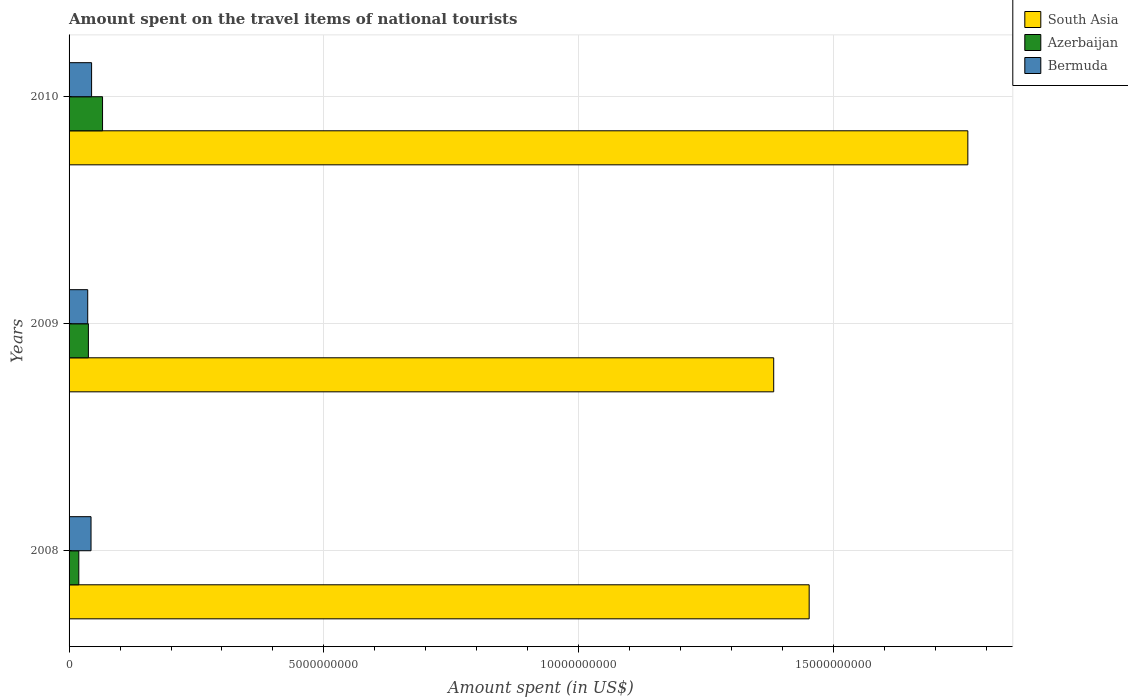How many groups of bars are there?
Your response must be concise. 3. How many bars are there on the 1st tick from the top?
Give a very brief answer. 3. What is the label of the 3rd group of bars from the top?
Your answer should be compact. 2008. What is the amount spent on the travel items of national tourists in Bermuda in 2009?
Make the answer very short. 3.66e+08. Across all years, what is the maximum amount spent on the travel items of national tourists in Bermuda?
Provide a succinct answer. 4.42e+08. Across all years, what is the minimum amount spent on the travel items of national tourists in South Asia?
Provide a short and direct response. 1.38e+1. In which year was the amount spent on the travel items of national tourists in South Asia maximum?
Provide a short and direct response. 2010. What is the total amount spent on the travel items of national tourists in South Asia in the graph?
Ensure brevity in your answer.  4.60e+1. What is the difference between the amount spent on the travel items of national tourists in Bermuda in 2008 and that in 2009?
Keep it short and to the point. 6.50e+07. What is the difference between the amount spent on the travel items of national tourists in Bermuda in 2010 and the amount spent on the travel items of national tourists in South Asia in 2009?
Your answer should be very brief. -1.34e+1. What is the average amount spent on the travel items of national tourists in Azerbaijan per year?
Ensure brevity in your answer.  4.09e+08. In the year 2008, what is the difference between the amount spent on the travel items of national tourists in Azerbaijan and amount spent on the travel items of national tourists in South Asia?
Offer a very short reply. -1.43e+1. What is the ratio of the amount spent on the travel items of national tourists in Bermuda in 2008 to that in 2009?
Provide a succinct answer. 1.18. Is the difference between the amount spent on the travel items of national tourists in Azerbaijan in 2009 and 2010 greater than the difference between the amount spent on the travel items of national tourists in South Asia in 2009 and 2010?
Your response must be concise. Yes. What is the difference between the highest and the second highest amount spent on the travel items of national tourists in Azerbaijan?
Give a very brief answer. 2.78e+08. What is the difference between the highest and the lowest amount spent on the travel items of national tourists in Azerbaijan?
Your answer should be compact. 4.66e+08. In how many years, is the amount spent on the travel items of national tourists in South Asia greater than the average amount spent on the travel items of national tourists in South Asia taken over all years?
Your answer should be compact. 1. Is the sum of the amount spent on the travel items of national tourists in South Asia in 2009 and 2010 greater than the maximum amount spent on the travel items of national tourists in Bermuda across all years?
Provide a short and direct response. Yes. What does the 1st bar from the bottom in 2009 represents?
Your answer should be compact. South Asia. How many years are there in the graph?
Provide a short and direct response. 3. Does the graph contain grids?
Provide a succinct answer. Yes. Where does the legend appear in the graph?
Offer a terse response. Top right. How are the legend labels stacked?
Ensure brevity in your answer.  Vertical. What is the title of the graph?
Make the answer very short. Amount spent on the travel items of national tourists. What is the label or title of the X-axis?
Your answer should be compact. Amount spent (in US$). What is the Amount spent (in US$) of South Asia in 2008?
Ensure brevity in your answer.  1.45e+1. What is the Amount spent (in US$) in Azerbaijan in 2008?
Your answer should be compact. 1.91e+08. What is the Amount spent (in US$) in Bermuda in 2008?
Provide a succinct answer. 4.31e+08. What is the Amount spent (in US$) in South Asia in 2009?
Your answer should be compact. 1.38e+1. What is the Amount spent (in US$) in Azerbaijan in 2009?
Make the answer very short. 3.79e+08. What is the Amount spent (in US$) in Bermuda in 2009?
Offer a very short reply. 3.66e+08. What is the Amount spent (in US$) of South Asia in 2010?
Offer a very short reply. 1.76e+1. What is the Amount spent (in US$) of Azerbaijan in 2010?
Your answer should be compact. 6.57e+08. What is the Amount spent (in US$) in Bermuda in 2010?
Make the answer very short. 4.42e+08. Across all years, what is the maximum Amount spent (in US$) in South Asia?
Your answer should be very brief. 1.76e+1. Across all years, what is the maximum Amount spent (in US$) of Azerbaijan?
Offer a very short reply. 6.57e+08. Across all years, what is the maximum Amount spent (in US$) in Bermuda?
Your answer should be very brief. 4.42e+08. Across all years, what is the minimum Amount spent (in US$) in South Asia?
Make the answer very short. 1.38e+1. Across all years, what is the minimum Amount spent (in US$) in Azerbaijan?
Your answer should be very brief. 1.91e+08. Across all years, what is the minimum Amount spent (in US$) of Bermuda?
Your answer should be compact. 3.66e+08. What is the total Amount spent (in US$) of South Asia in the graph?
Offer a terse response. 4.60e+1. What is the total Amount spent (in US$) of Azerbaijan in the graph?
Your answer should be compact. 1.23e+09. What is the total Amount spent (in US$) in Bermuda in the graph?
Keep it short and to the point. 1.24e+09. What is the difference between the Amount spent (in US$) of South Asia in 2008 and that in 2009?
Offer a terse response. 6.96e+08. What is the difference between the Amount spent (in US$) of Azerbaijan in 2008 and that in 2009?
Your answer should be compact. -1.88e+08. What is the difference between the Amount spent (in US$) of Bermuda in 2008 and that in 2009?
Provide a short and direct response. 6.50e+07. What is the difference between the Amount spent (in US$) of South Asia in 2008 and that in 2010?
Your answer should be very brief. -3.11e+09. What is the difference between the Amount spent (in US$) in Azerbaijan in 2008 and that in 2010?
Ensure brevity in your answer.  -4.66e+08. What is the difference between the Amount spent (in US$) in Bermuda in 2008 and that in 2010?
Keep it short and to the point. -1.10e+07. What is the difference between the Amount spent (in US$) in South Asia in 2009 and that in 2010?
Provide a succinct answer. -3.81e+09. What is the difference between the Amount spent (in US$) in Azerbaijan in 2009 and that in 2010?
Offer a terse response. -2.78e+08. What is the difference between the Amount spent (in US$) in Bermuda in 2009 and that in 2010?
Make the answer very short. -7.60e+07. What is the difference between the Amount spent (in US$) in South Asia in 2008 and the Amount spent (in US$) in Azerbaijan in 2009?
Provide a succinct answer. 1.41e+1. What is the difference between the Amount spent (in US$) in South Asia in 2008 and the Amount spent (in US$) in Bermuda in 2009?
Your answer should be compact. 1.42e+1. What is the difference between the Amount spent (in US$) of Azerbaijan in 2008 and the Amount spent (in US$) of Bermuda in 2009?
Your answer should be compact. -1.75e+08. What is the difference between the Amount spent (in US$) of South Asia in 2008 and the Amount spent (in US$) of Azerbaijan in 2010?
Ensure brevity in your answer.  1.39e+1. What is the difference between the Amount spent (in US$) in South Asia in 2008 and the Amount spent (in US$) in Bermuda in 2010?
Keep it short and to the point. 1.41e+1. What is the difference between the Amount spent (in US$) of Azerbaijan in 2008 and the Amount spent (in US$) of Bermuda in 2010?
Provide a succinct answer. -2.51e+08. What is the difference between the Amount spent (in US$) in South Asia in 2009 and the Amount spent (in US$) in Azerbaijan in 2010?
Ensure brevity in your answer.  1.32e+1. What is the difference between the Amount spent (in US$) in South Asia in 2009 and the Amount spent (in US$) in Bermuda in 2010?
Ensure brevity in your answer.  1.34e+1. What is the difference between the Amount spent (in US$) in Azerbaijan in 2009 and the Amount spent (in US$) in Bermuda in 2010?
Give a very brief answer. -6.30e+07. What is the average Amount spent (in US$) of South Asia per year?
Your response must be concise. 1.53e+1. What is the average Amount spent (in US$) in Azerbaijan per year?
Your response must be concise. 4.09e+08. What is the average Amount spent (in US$) of Bermuda per year?
Keep it short and to the point. 4.13e+08. In the year 2008, what is the difference between the Amount spent (in US$) of South Asia and Amount spent (in US$) of Azerbaijan?
Give a very brief answer. 1.43e+1. In the year 2008, what is the difference between the Amount spent (in US$) of South Asia and Amount spent (in US$) of Bermuda?
Your response must be concise. 1.41e+1. In the year 2008, what is the difference between the Amount spent (in US$) of Azerbaijan and Amount spent (in US$) of Bermuda?
Your response must be concise. -2.40e+08. In the year 2009, what is the difference between the Amount spent (in US$) of South Asia and Amount spent (in US$) of Azerbaijan?
Your answer should be very brief. 1.34e+1. In the year 2009, what is the difference between the Amount spent (in US$) of South Asia and Amount spent (in US$) of Bermuda?
Keep it short and to the point. 1.35e+1. In the year 2009, what is the difference between the Amount spent (in US$) in Azerbaijan and Amount spent (in US$) in Bermuda?
Give a very brief answer. 1.30e+07. In the year 2010, what is the difference between the Amount spent (in US$) of South Asia and Amount spent (in US$) of Azerbaijan?
Your response must be concise. 1.70e+1. In the year 2010, what is the difference between the Amount spent (in US$) of South Asia and Amount spent (in US$) of Bermuda?
Provide a short and direct response. 1.72e+1. In the year 2010, what is the difference between the Amount spent (in US$) in Azerbaijan and Amount spent (in US$) in Bermuda?
Your answer should be compact. 2.15e+08. What is the ratio of the Amount spent (in US$) in South Asia in 2008 to that in 2009?
Offer a terse response. 1.05. What is the ratio of the Amount spent (in US$) in Azerbaijan in 2008 to that in 2009?
Give a very brief answer. 0.5. What is the ratio of the Amount spent (in US$) in Bermuda in 2008 to that in 2009?
Ensure brevity in your answer.  1.18. What is the ratio of the Amount spent (in US$) of South Asia in 2008 to that in 2010?
Your response must be concise. 0.82. What is the ratio of the Amount spent (in US$) of Azerbaijan in 2008 to that in 2010?
Offer a very short reply. 0.29. What is the ratio of the Amount spent (in US$) of Bermuda in 2008 to that in 2010?
Provide a succinct answer. 0.98. What is the ratio of the Amount spent (in US$) of South Asia in 2009 to that in 2010?
Keep it short and to the point. 0.78. What is the ratio of the Amount spent (in US$) in Azerbaijan in 2009 to that in 2010?
Your answer should be compact. 0.58. What is the ratio of the Amount spent (in US$) in Bermuda in 2009 to that in 2010?
Offer a terse response. 0.83. What is the difference between the highest and the second highest Amount spent (in US$) in South Asia?
Make the answer very short. 3.11e+09. What is the difference between the highest and the second highest Amount spent (in US$) in Azerbaijan?
Your response must be concise. 2.78e+08. What is the difference between the highest and the second highest Amount spent (in US$) in Bermuda?
Make the answer very short. 1.10e+07. What is the difference between the highest and the lowest Amount spent (in US$) of South Asia?
Provide a succinct answer. 3.81e+09. What is the difference between the highest and the lowest Amount spent (in US$) in Azerbaijan?
Offer a terse response. 4.66e+08. What is the difference between the highest and the lowest Amount spent (in US$) of Bermuda?
Keep it short and to the point. 7.60e+07. 